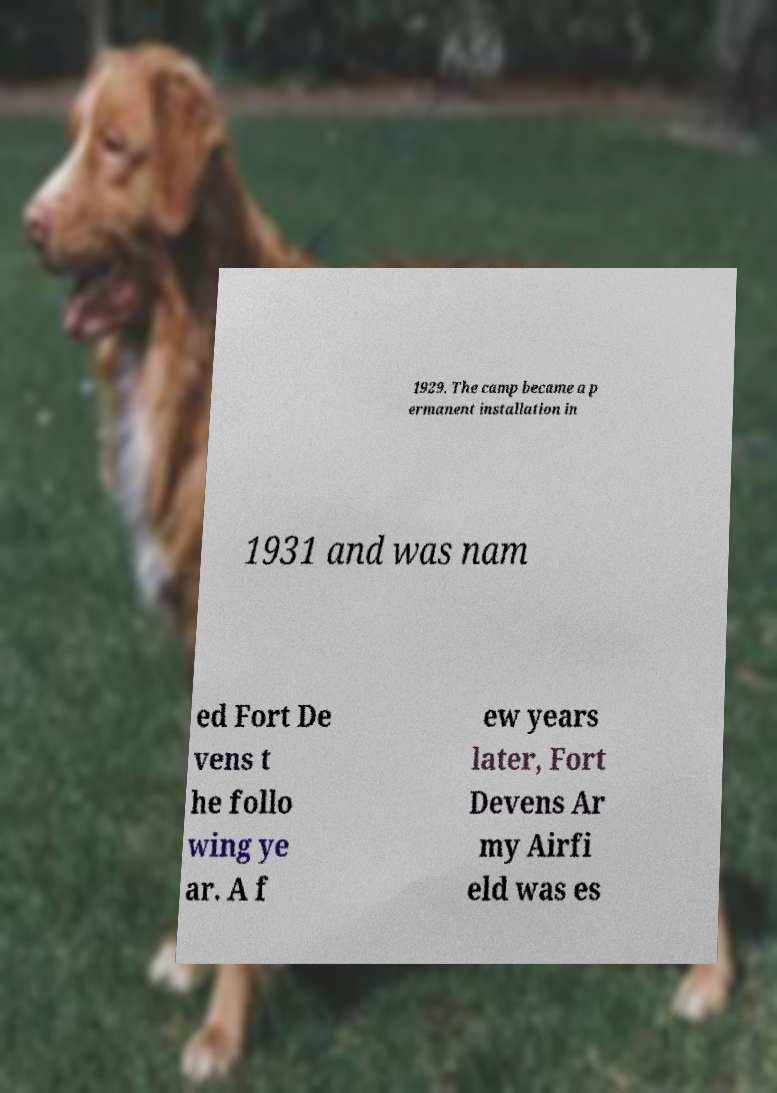Could you extract and type out the text from this image? 1929. The camp became a p ermanent installation in 1931 and was nam ed Fort De vens t he follo wing ye ar. A f ew years later, Fort Devens Ar my Airfi eld was es 